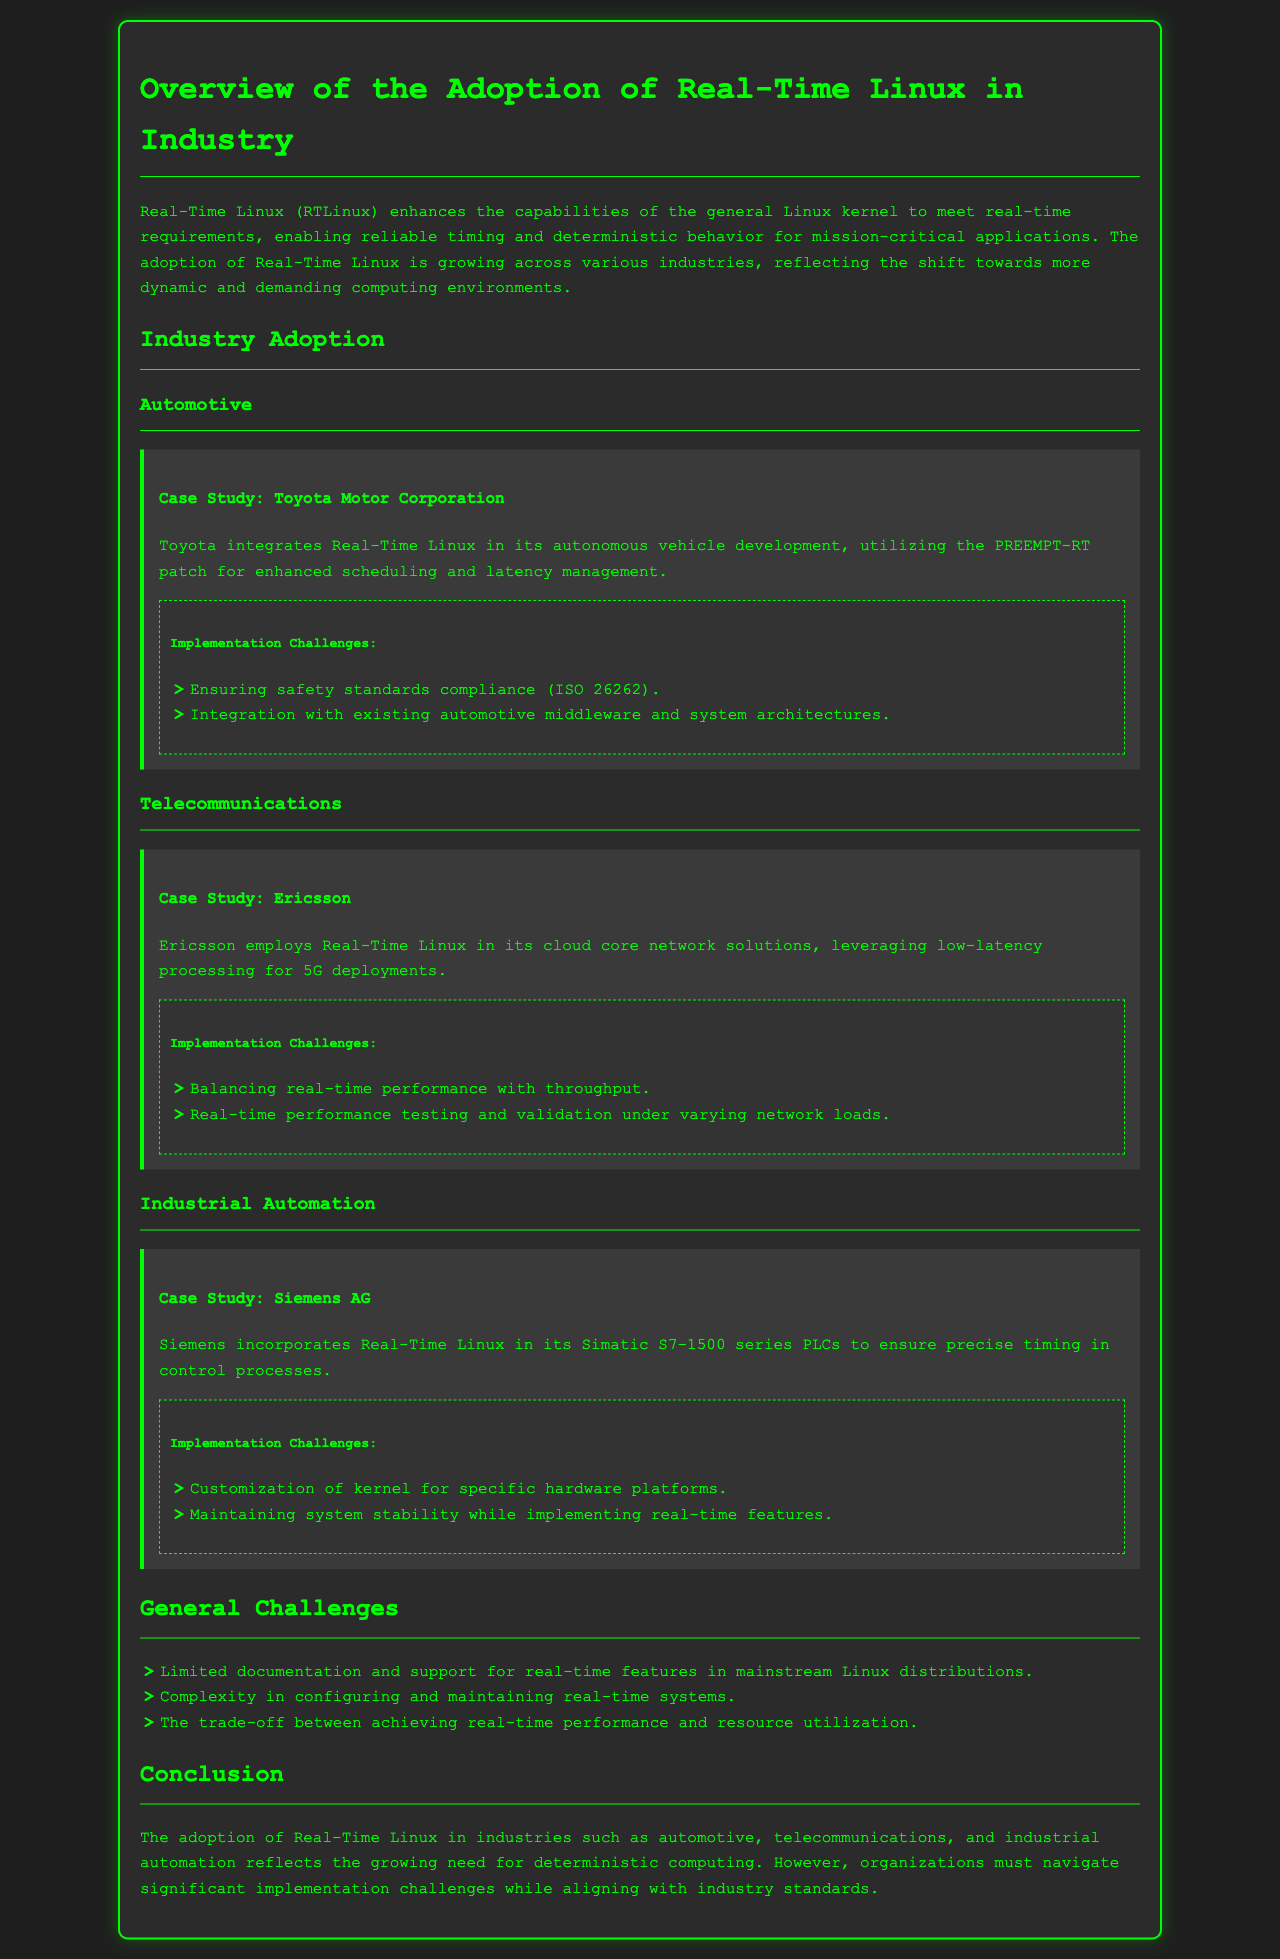What is the first industry mentioned in the document? The first industry mentioned is automotive, as it is the first section under "Industry Adoption".
Answer: automotive Who developed the PREEMPT-RT patch? The PREEMPT-RT patch is utilized by organizations like Toyota for enhancing scheduling in their systems, but the document does not specify the developer. However, PREEMPT-RT is a community-driven effort.
Answer: community-driven effort What safety standard must be complied with in Toyota's implementation? The safety standard mentioned is ISO 26262.
Answer: ISO 26262 Which company uses Real-Time Linux for cloud core network solutions? The company using Real-Time Linux for cloud core network solutions is Ericsson.
Answer: Ericsson What is one challenge faced by Siemens AG in implementing Real-Time Linux? One challenge faced by Siemens AG is the customization of the kernel for specific hardware platforms.
Answer: customization of kernel for specific hardware platforms What is a general challenge mentioned in the document regarding Real-Time Linux? One general challenge mentioned is the limited documentation and support for real-time features in mainstream Linux distributions.
Answer: limited documentation and support How does Real-Time Linux benefit the telecommunications industry? Real-Time Linux benefits telecommunications by providing low-latency processing for 5G deployments.
Answer: low-latency processing for 5G deployments What is an overarching theme of the document? The overarching theme of the document is the growing adoption of Real-Time Linux in various industries to meet deterministic computing requirements.
Answer: growing adoption of Real-Time Linux 